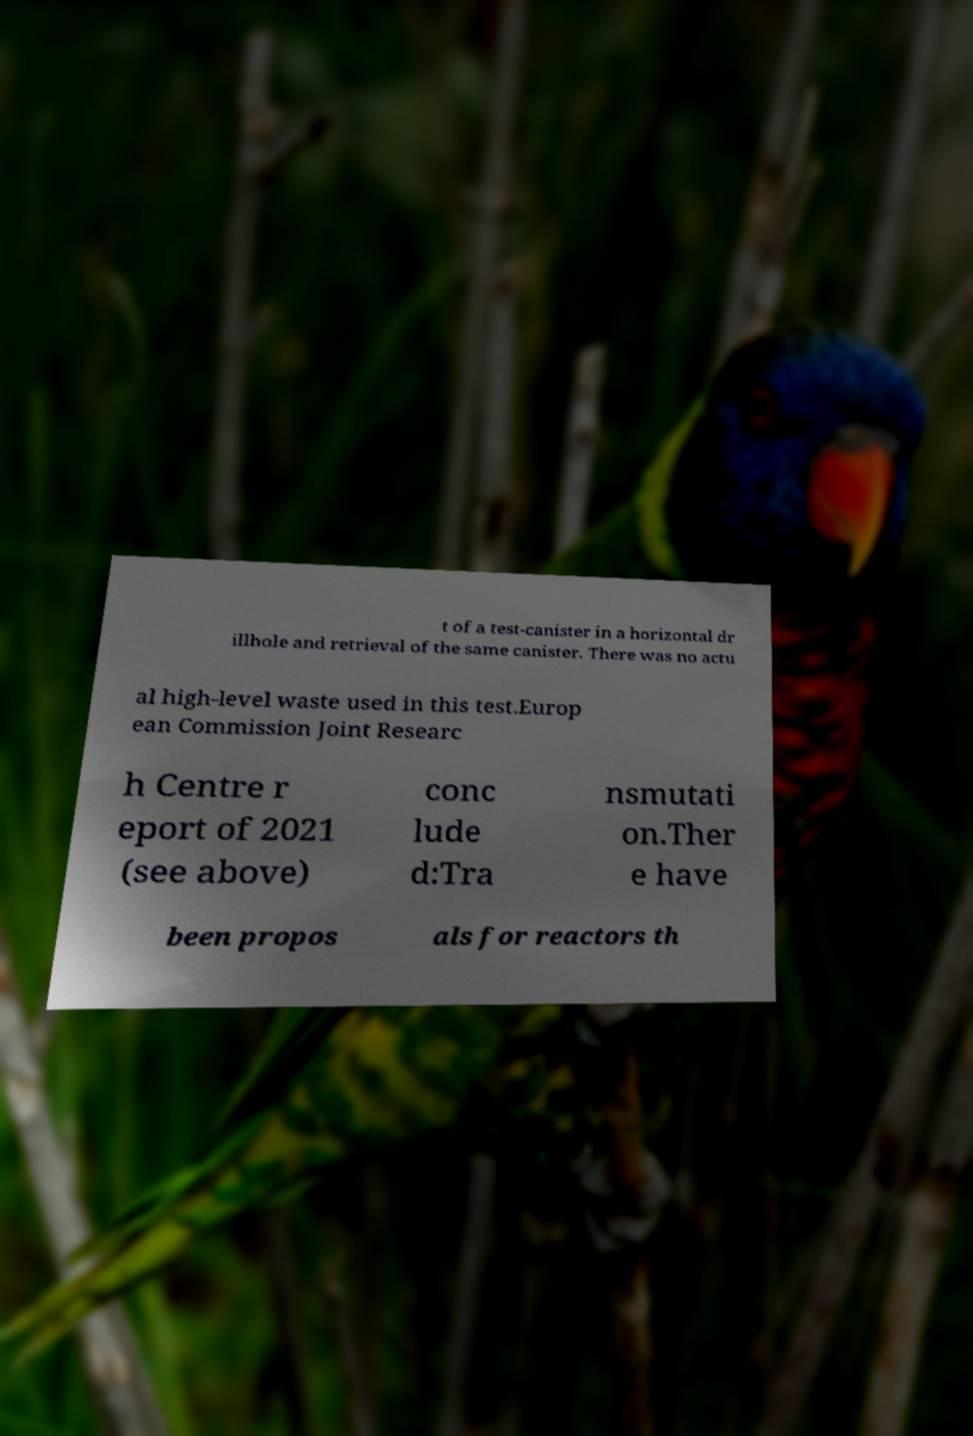There's text embedded in this image that I need extracted. Can you transcribe it verbatim? t of a test-canister in a horizontal dr illhole and retrieval of the same canister. There was no actu al high-level waste used in this test.Europ ean Commission Joint Researc h Centre r eport of 2021 (see above) conc lude d:Tra nsmutati on.Ther e have been propos als for reactors th 